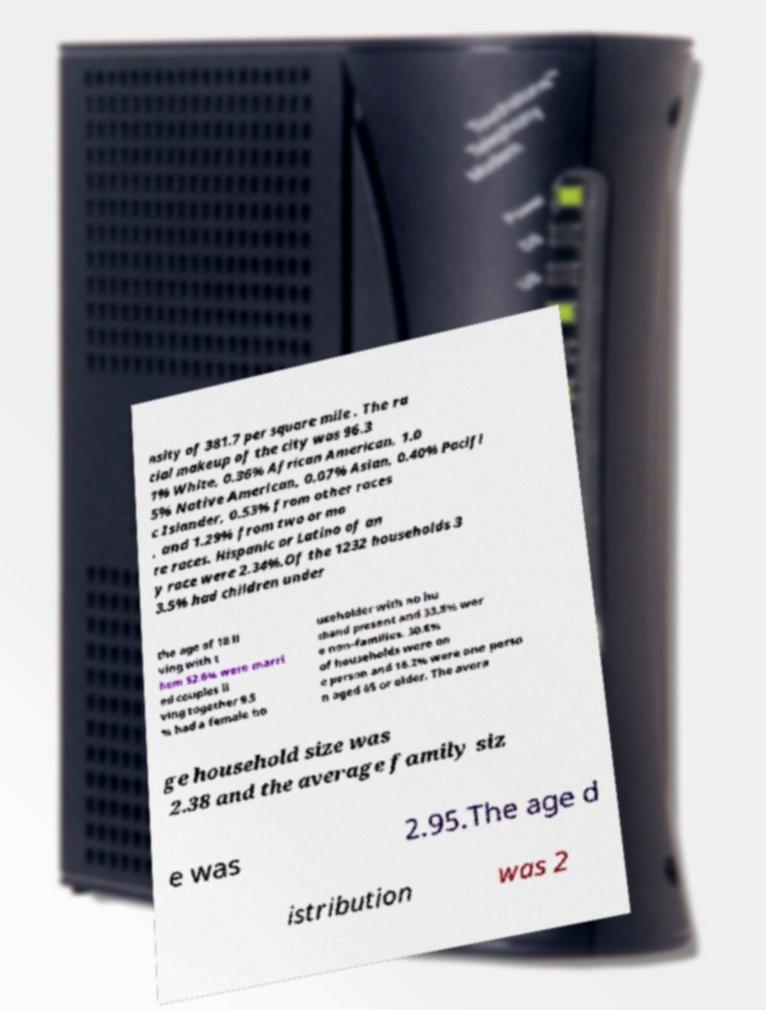Can you accurately transcribe the text from the provided image for me? nsity of 381.7 per square mile . The ra cial makeup of the city was 96.3 1% White, 0.36% African American, 1.0 5% Native American, 0.07% Asian, 0.40% Pacifi c Islander, 0.53% from other races , and 1.29% from two or mo re races. Hispanic or Latino of an y race were 2.34%.Of the 1232 households 3 3.5% had children under the age of 18 li ving with t hem 52.6% were marri ed couples li ving together 9.5 % had a female ho useholder with no hu sband present and 33.8% wer e non-families. 30.8% of households were on e person and 16.2% were one perso n aged 65 or older. The avera ge household size was 2.38 and the average family siz e was 2.95.The age d istribution was 2 